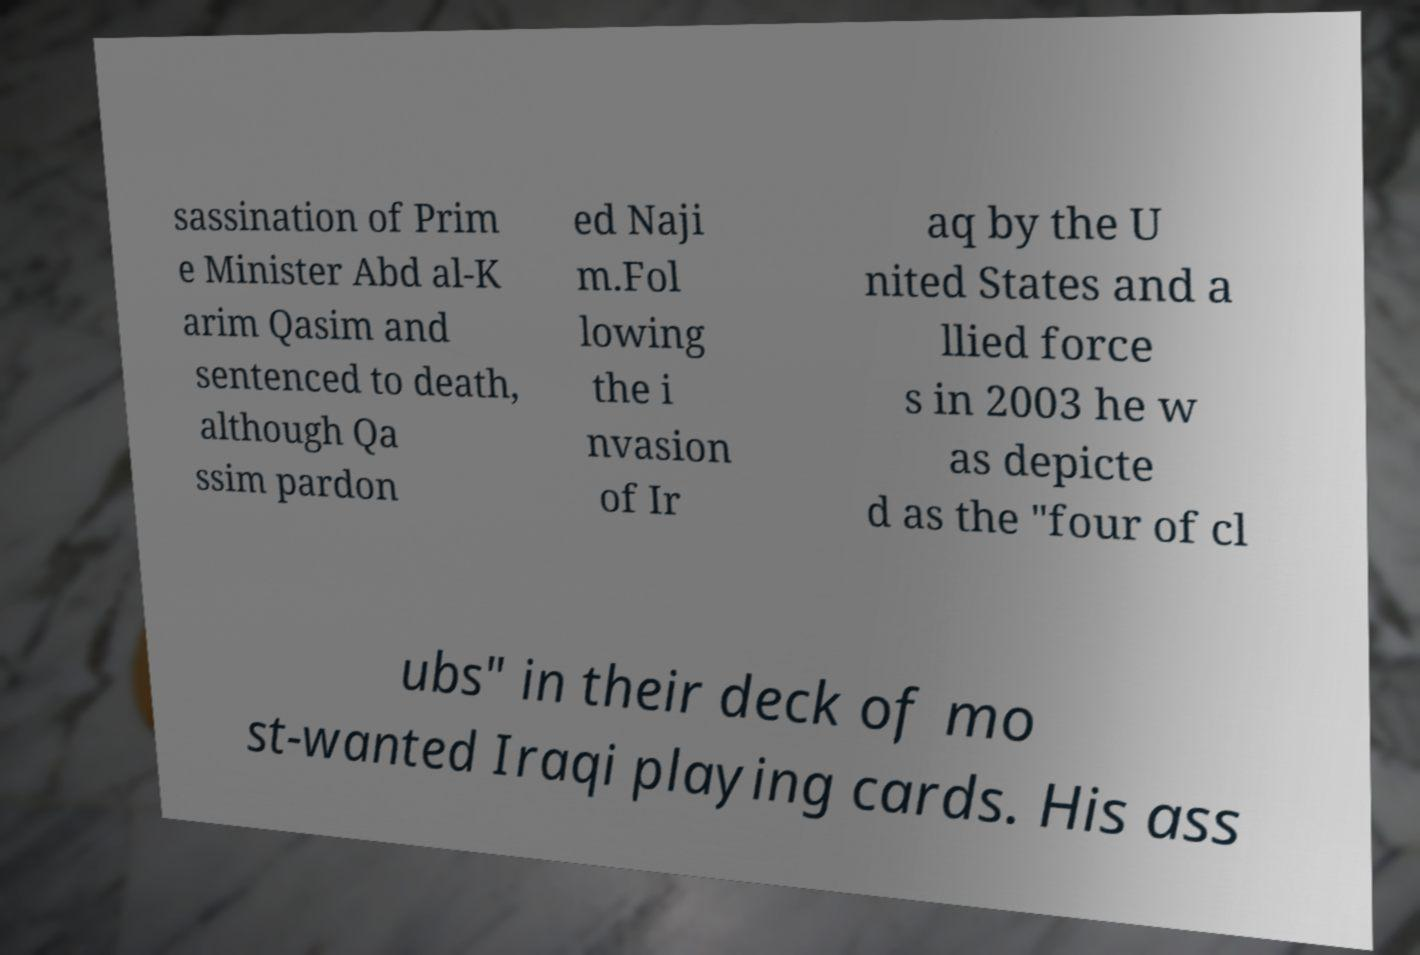Can you read and provide the text displayed in the image?This photo seems to have some interesting text. Can you extract and type it out for me? sassination of Prim e Minister Abd al-K arim Qasim and sentenced to death, although Qa ssim pardon ed Naji m.Fol lowing the i nvasion of Ir aq by the U nited States and a llied force s in 2003 he w as depicte d as the "four of cl ubs" in their deck of mo st-wanted Iraqi playing cards. His ass 